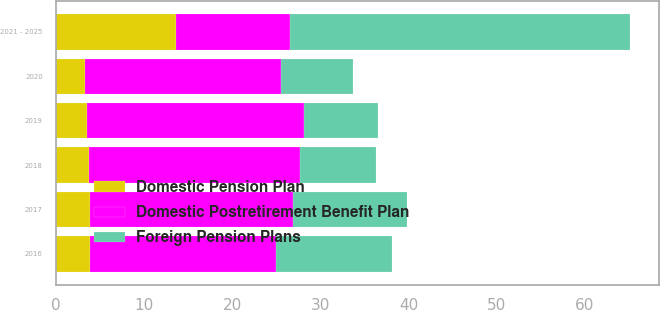Convert chart to OTSL. <chart><loc_0><loc_0><loc_500><loc_500><stacked_bar_chart><ecel><fcel>2016<fcel>2017<fcel>2018<fcel>2019<fcel>2020<fcel>2021 - 2025<nl><fcel>Foreign Pension Plans<fcel>13.1<fcel>12.9<fcel>8.6<fcel>8.4<fcel>8.2<fcel>38.7<nl><fcel>Domestic Postretirement Benefit Plan<fcel>21.1<fcel>23.1<fcel>24<fcel>24.6<fcel>22.2<fcel>12.9<nl><fcel>Domestic Pension Plan<fcel>3.9<fcel>3.8<fcel>3.7<fcel>3.5<fcel>3.3<fcel>13.6<nl></chart> 